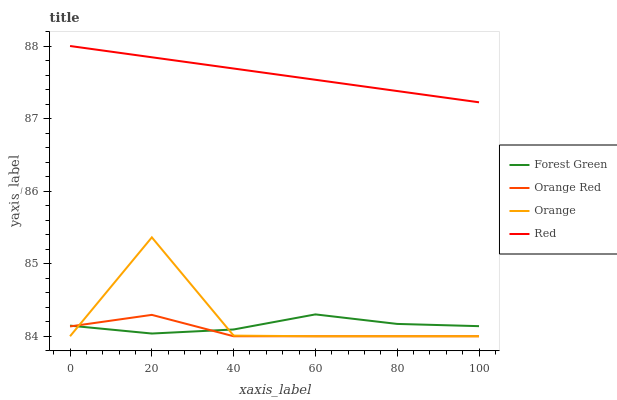Does Forest Green have the minimum area under the curve?
Answer yes or no. No. Does Forest Green have the maximum area under the curve?
Answer yes or no. No. Is Forest Green the smoothest?
Answer yes or no. No. Is Forest Green the roughest?
Answer yes or no. No. Does Forest Green have the lowest value?
Answer yes or no. No. Does Forest Green have the highest value?
Answer yes or no. No. Is Forest Green less than Red?
Answer yes or no. Yes. Is Red greater than Orange?
Answer yes or no. Yes. Does Forest Green intersect Red?
Answer yes or no. No. 